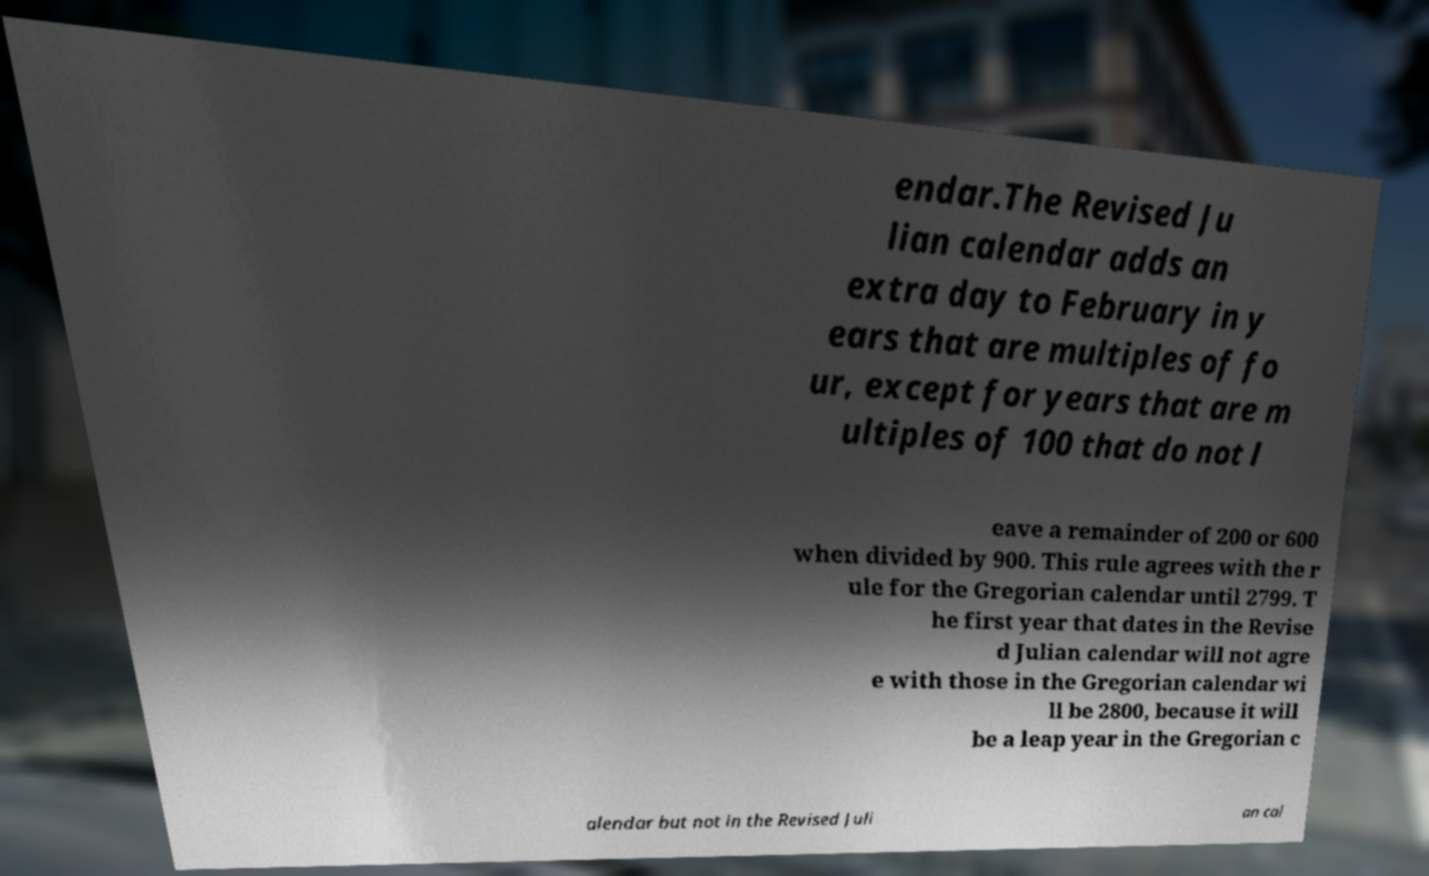Could you extract and type out the text from this image? endar.The Revised Ju lian calendar adds an extra day to February in y ears that are multiples of fo ur, except for years that are m ultiples of 100 that do not l eave a remainder of 200 or 600 when divided by 900. This rule agrees with the r ule for the Gregorian calendar until 2799. T he first year that dates in the Revise d Julian calendar will not agre e with those in the Gregorian calendar wi ll be 2800, because it will be a leap year in the Gregorian c alendar but not in the Revised Juli an cal 